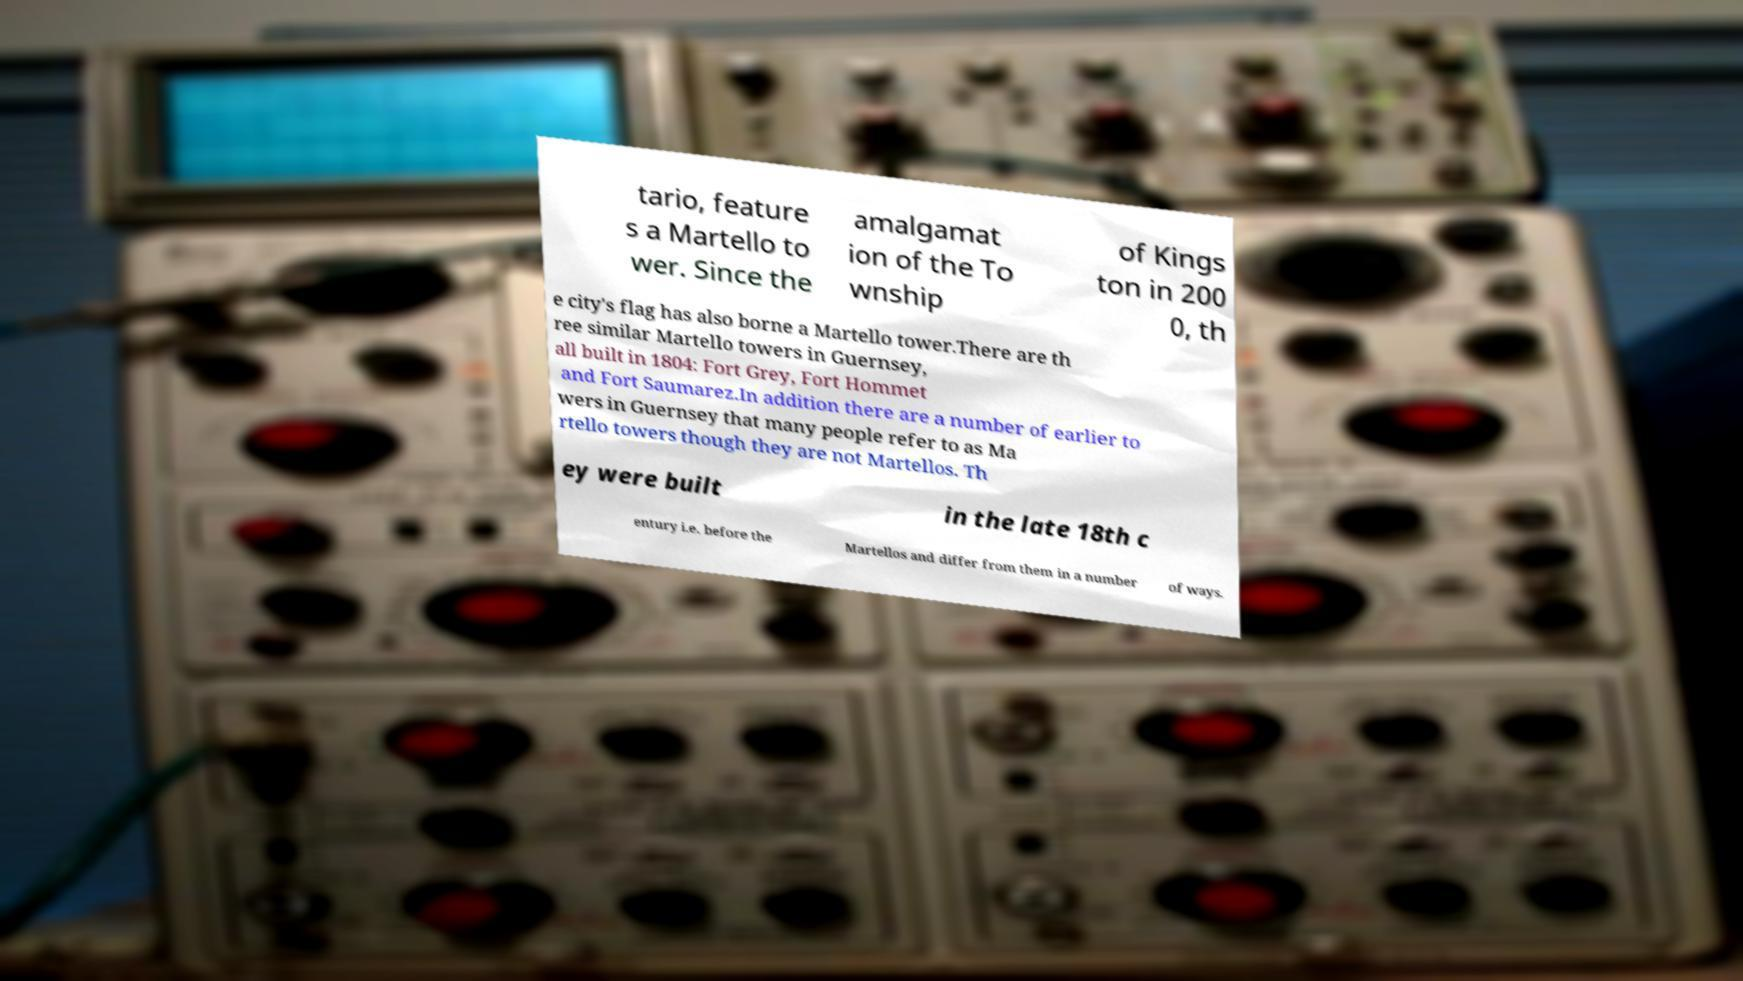I need the written content from this picture converted into text. Can you do that? tario, feature s a Martello to wer. Since the amalgamat ion of the To wnship of Kings ton in 200 0, th e city's flag has also borne a Martello tower.There are th ree similar Martello towers in Guernsey, all built in 1804: Fort Grey, Fort Hommet and Fort Saumarez.In addition there are a number of earlier to wers in Guernsey that many people refer to as Ma rtello towers though they are not Martellos. Th ey were built in the late 18th c entury i.e. before the Martellos and differ from them in a number of ways. 